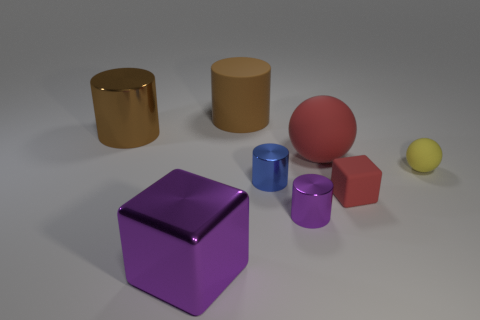Subtract all red blocks. How many brown cylinders are left? 2 Subtract all purple cylinders. How many cylinders are left? 3 Subtract all shiny cylinders. How many cylinders are left? 1 Add 2 purple cubes. How many objects exist? 10 Subtract 2 cylinders. How many cylinders are left? 2 Subtract all spheres. How many objects are left? 6 Subtract all red matte things. Subtract all tiny purple objects. How many objects are left? 5 Add 1 metallic cylinders. How many metallic cylinders are left? 4 Add 8 big brown spheres. How many big brown spheres exist? 8 Subtract 1 red blocks. How many objects are left? 7 